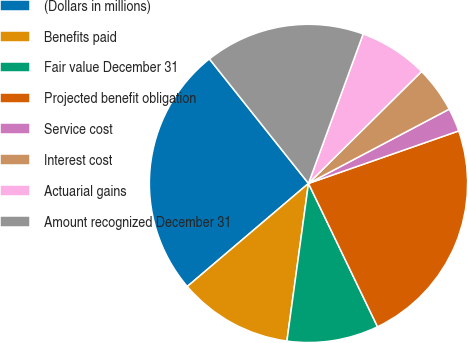Convert chart. <chart><loc_0><loc_0><loc_500><loc_500><pie_chart><fcel>(Dollars in millions)<fcel>Benefits paid<fcel>Fair value December 31<fcel>Projected benefit obligation<fcel>Service cost<fcel>Interest cost<fcel>Actuarial gains<fcel>Amount recognized December 31<nl><fcel>25.52%<fcel>11.62%<fcel>9.31%<fcel>23.21%<fcel>2.38%<fcel>4.69%<fcel>7.0%<fcel>16.28%<nl></chart> 